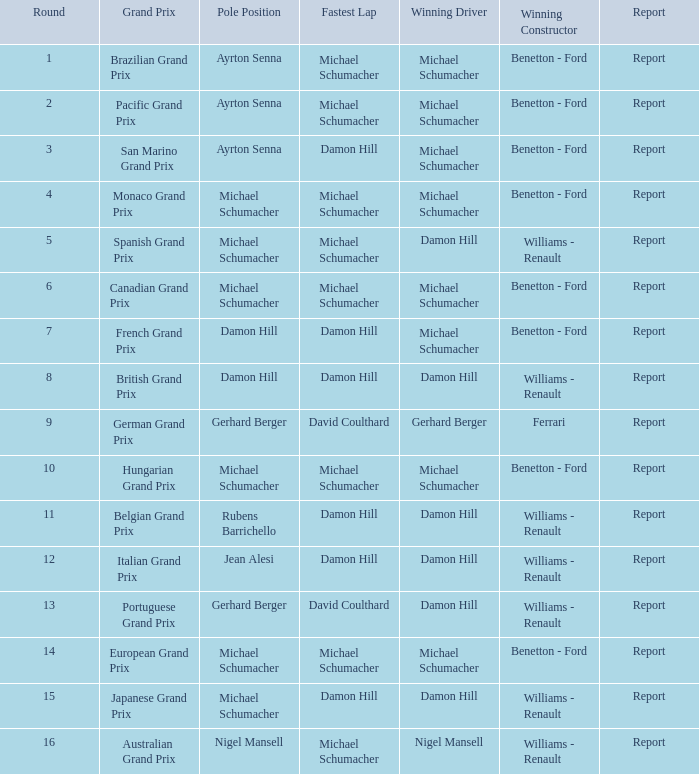What is the quickest lap time for the brazilian grand prix? Michael Schumacher. 